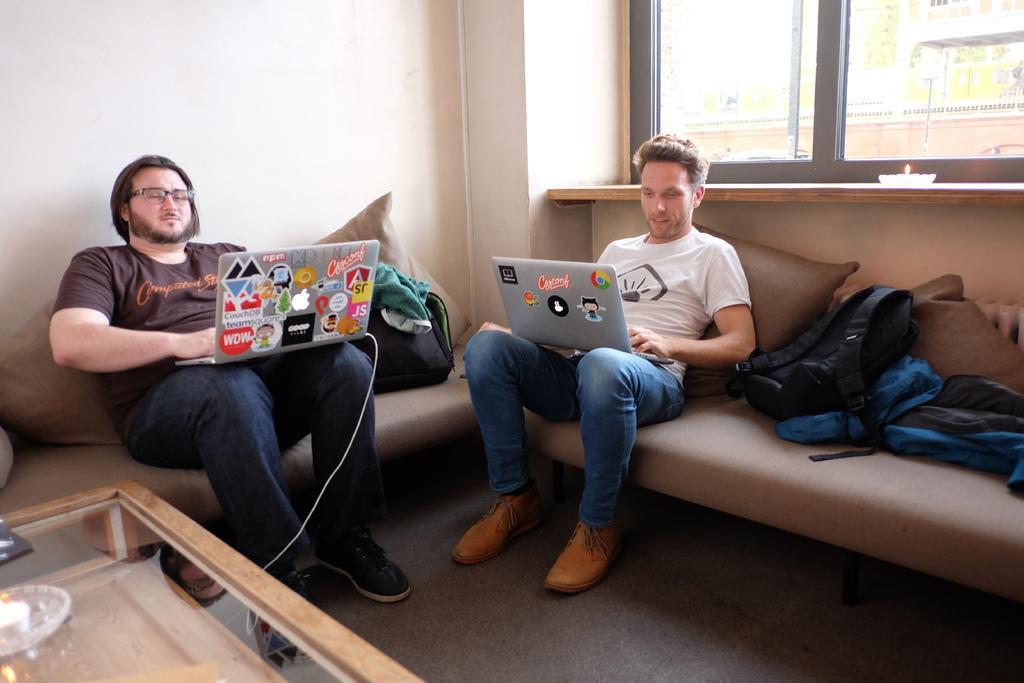Describe this image in one or two sentences. in the picture there is a living room, in which two persons are sitting on a sofa and working with a laptop,here there are some bags on the sofa. 